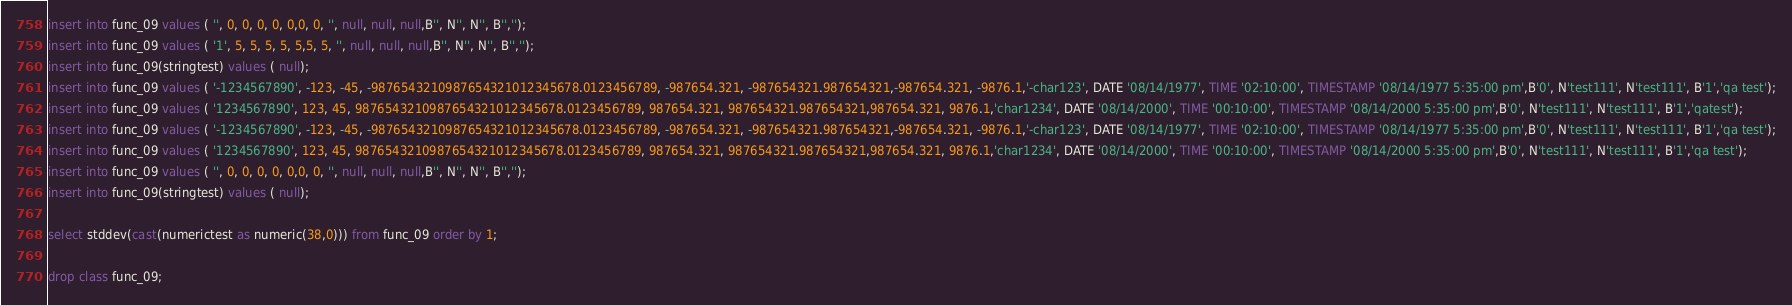<code> <loc_0><loc_0><loc_500><loc_500><_SQL_>insert into func_09 values ( '', 0, 0, 0, 0, 0,0, 0, '', null, null, null,B'', N'', N'', B'','');
insert into func_09 values ( '1', 5, 5, 5, 5, 5,5, 5, '', null, null, null,B'', N'', N'', B'','');
insert into func_09(stringtest) values ( null);
insert into func_09 values ( '-1234567890', -123, -45, -9876543210987654321012345678.0123456789, -987654.321, -987654321.987654321,-987654.321, -9876.1,'-char123', DATE '08/14/1977', TIME '02:10:00', TIMESTAMP '08/14/1977 5:35:00 pm',B'0', N'test111', N'test111', B'1','qa test');
insert into func_09 values ( '1234567890', 123, 45, 9876543210987654321012345678.0123456789, 987654.321, 987654321.987654321,987654.321, 9876.1,'char1234', DATE '08/14/2000', TIME '00:10:00', TIMESTAMP '08/14/2000 5:35:00 pm',B'0', N'test111', N'test111', B'1','qatest');
insert into func_09 values ( '-1234567890', -123, -45, -9876543210987654321012345678.0123456789, -987654.321, -987654321.987654321,-987654.321, -9876.1,'-char123', DATE '08/14/1977', TIME '02:10:00', TIMESTAMP '08/14/1977 5:35:00 pm',B'0', N'test111', N'test111', B'1','qa test');
insert into func_09 values ( '1234567890', 123, 45, 9876543210987654321012345678.0123456789, 987654.321, 987654321.987654321,987654.321, 9876.1,'char1234', DATE '08/14/2000', TIME '00:10:00', TIMESTAMP '08/14/2000 5:35:00 pm',B'0', N'test111', N'test111', B'1','qa test');
insert into func_09 values ( '', 0, 0, 0, 0, 0,0, 0, '', null, null, null,B'', N'', N'', B'','');
insert into func_09(stringtest) values ( null);

select stddev(cast(numerictest as numeric(38,0))) from func_09 order by 1;

drop class func_09;
</code> 